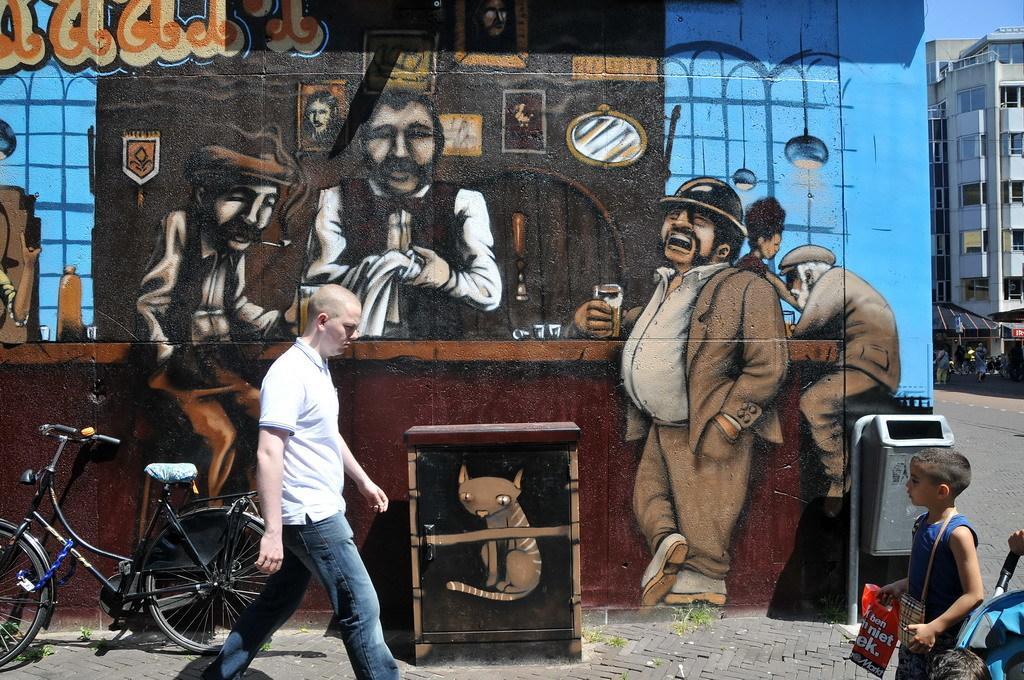In one or two sentences, can you explain what this image depicts? In this picture we can see painting on the wall. We can see a trash can and a bicycle. In the middle portion of the picture we can see a man walking on the pathway. On the right side of the picture we can see a boy wearing a bag and holding a polythene carry bag. We can see a building. We can see people and objects. 